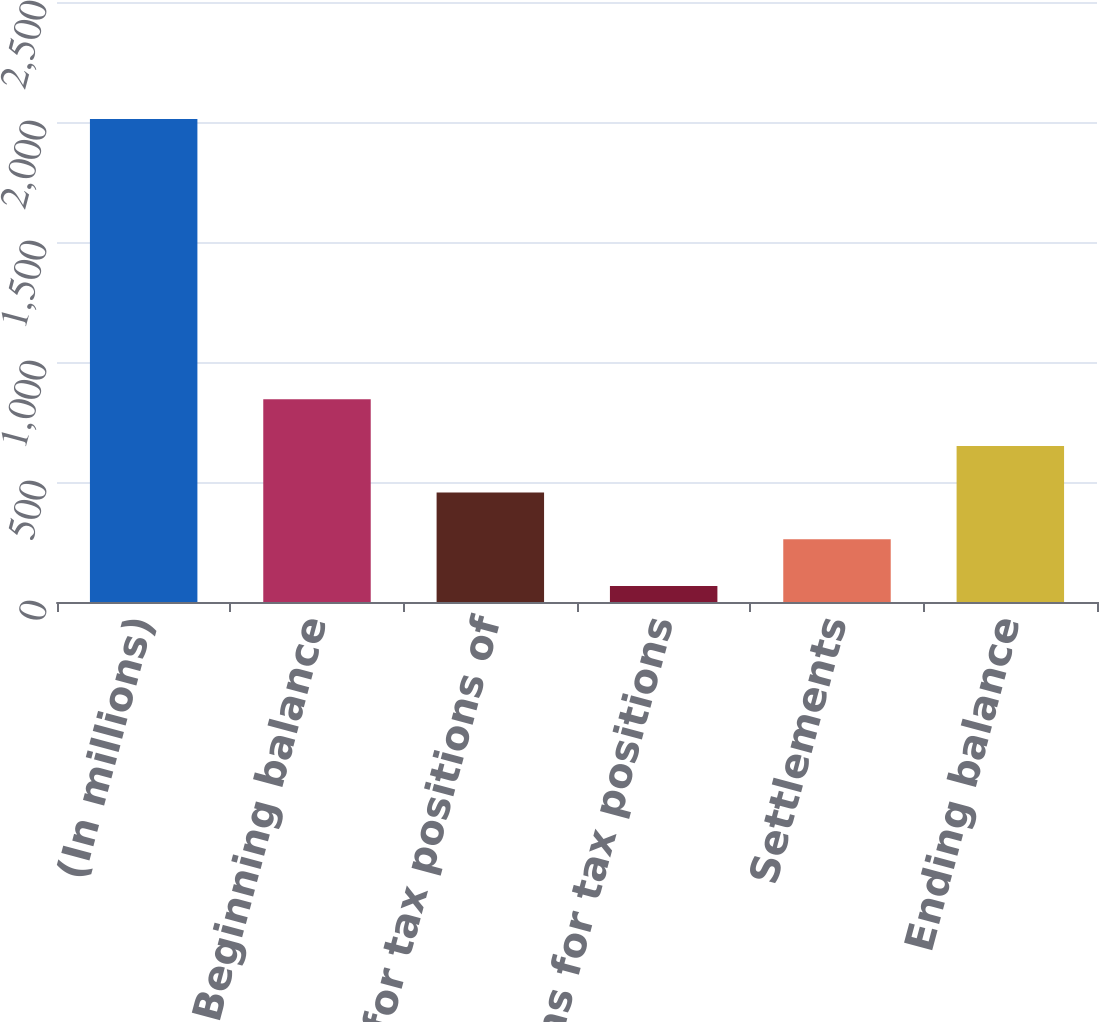<chart> <loc_0><loc_0><loc_500><loc_500><bar_chart><fcel>(In millions)<fcel>Beginning balance<fcel>Additions for tax positions of<fcel>Reductions for tax positions<fcel>Settlements<fcel>Ending balance<nl><fcel>2012<fcel>845<fcel>456<fcel>67<fcel>261.5<fcel>650.5<nl></chart> 